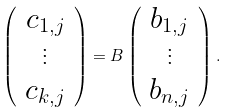<formula> <loc_0><loc_0><loc_500><loc_500>\left ( \begin{array} { c } c _ { 1 , j } \\ \vdots \\ c _ { k , j } \end{array} \right ) = B \left ( \begin{array} { c } b _ { 1 , j } \\ \vdots \\ b _ { n , j } \end{array} \right ) .</formula> 